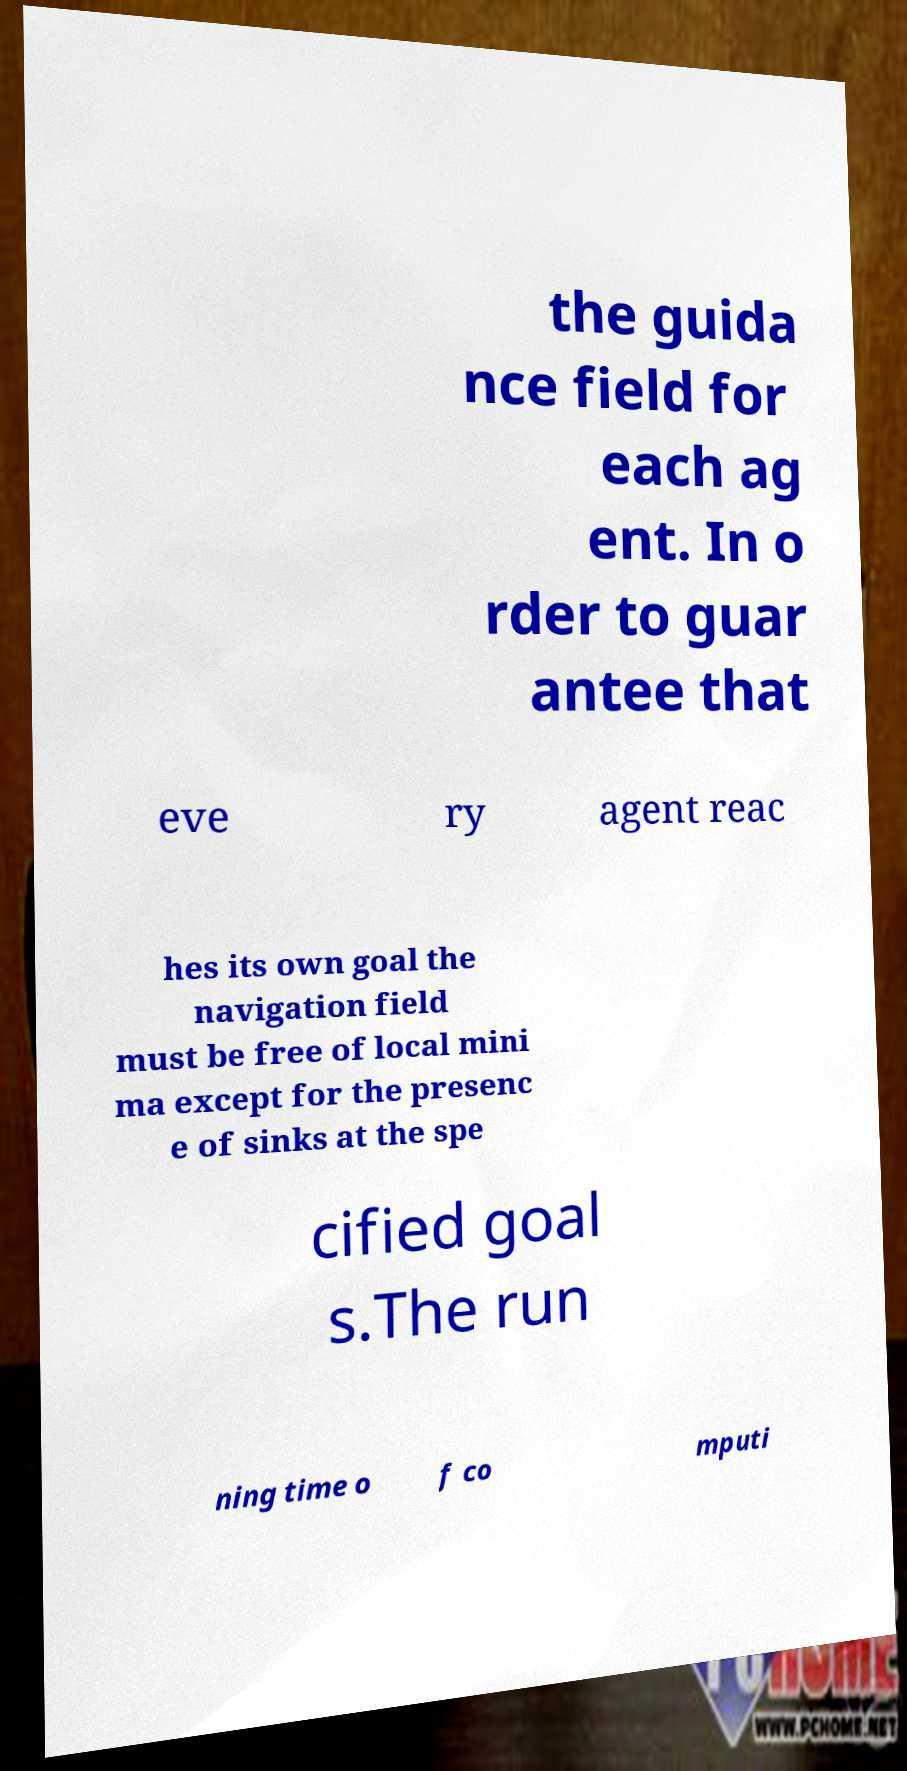Please identify and transcribe the text found in this image. the guida nce field for each ag ent. In o rder to guar antee that eve ry agent reac hes its own goal the navigation field must be free of local mini ma except for the presenc e of sinks at the spe cified goal s.The run ning time o f co mputi 